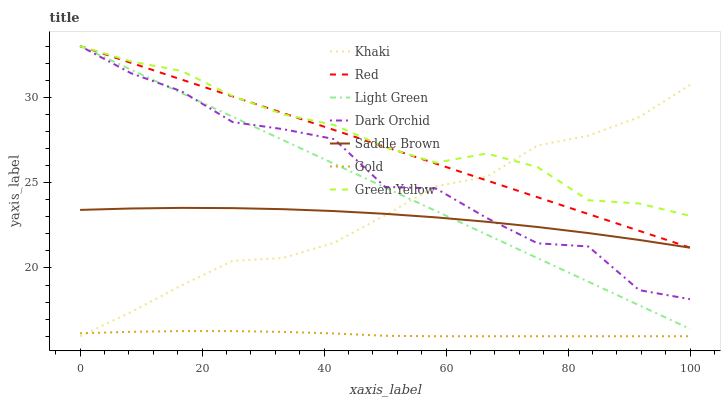Does Gold have the minimum area under the curve?
Answer yes or no. Yes. Does Green Yellow have the maximum area under the curve?
Answer yes or no. Yes. Does Dark Orchid have the minimum area under the curve?
Answer yes or no. No. Does Dark Orchid have the maximum area under the curve?
Answer yes or no. No. Is Red the smoothest?
Answer yes or no. Yes. Is Dark Orchid the roughest?
Answer yes or no. Yes. Is Gold the smoothest?
Answer yes or no. No. Is Gold the roughest?
Answer yes or no. No. Does Khaki have the lowest value?
Answer yes or no. Yes. Does Dark Orchid have the lowest value?
Answer yes or no. No. Does Red have the highest value?
Answer yes or no. Yes. Does Gold have the highest value?
Answer yes or no. No. Is Gold less than Dark Orchid?
Answer yes or no. Yes. Is Green Yellow greater than Saddle Brown?
Answer yes or no. Yes. Does Khaki intersect Saddle Brown?
Answer yes or no. Yes. Is Khaki less than Saddle Brown?
Answer yes or no. No. Is Khaki greater than Saddle Brown?
Answer yes or no. No. Does Gold intersect Dark Orchid?
Answer yes or no. No. 